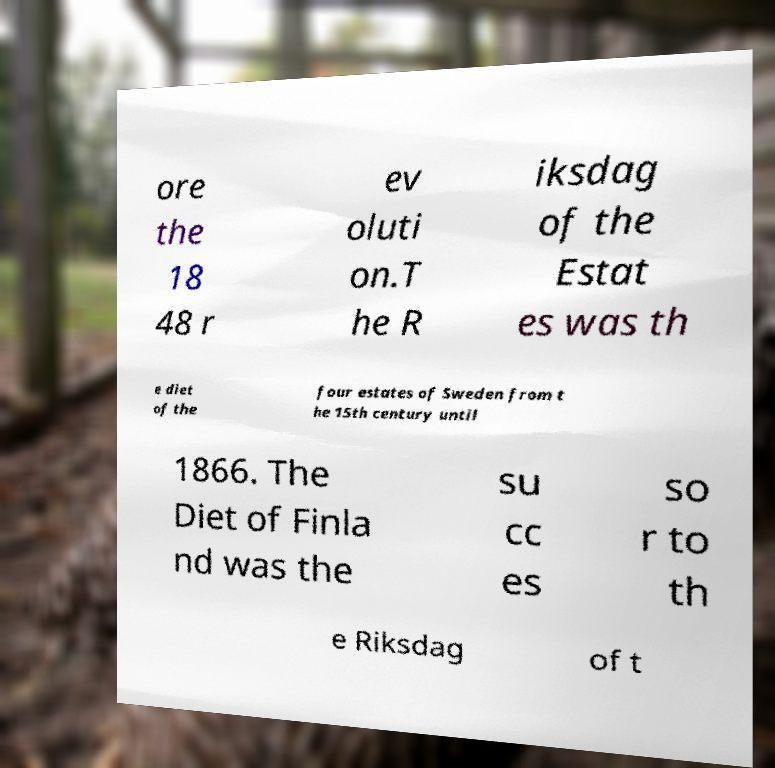Please identify and transcribe the text found in this image. ore the 18 48 r ev oluti on.T he R iksdag of the Estat es was th e diet of the four estates of Sweden from t he 15th century until 1866. The Diet of Finla nd was the su cc es so r to th e Riksdag of t 